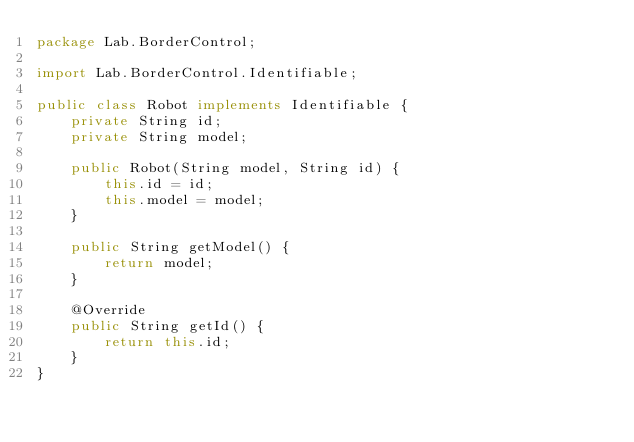Convert code to text. <code><loc_0><loc_0><loc_500><loc_500><_Java_>package Lab.BorderControl;

import Lab.BorderControl.Identifiable;

public class Robot implements Identifiable {
    private String id;
    private String model;

    public Robot(String model, String id) {
        this.id = id;
        this.model = model;
    }

    public String getModel() {
        return model;
    }

    @Override
    public String getId() {
        return this.id;
    }
}
</code> 